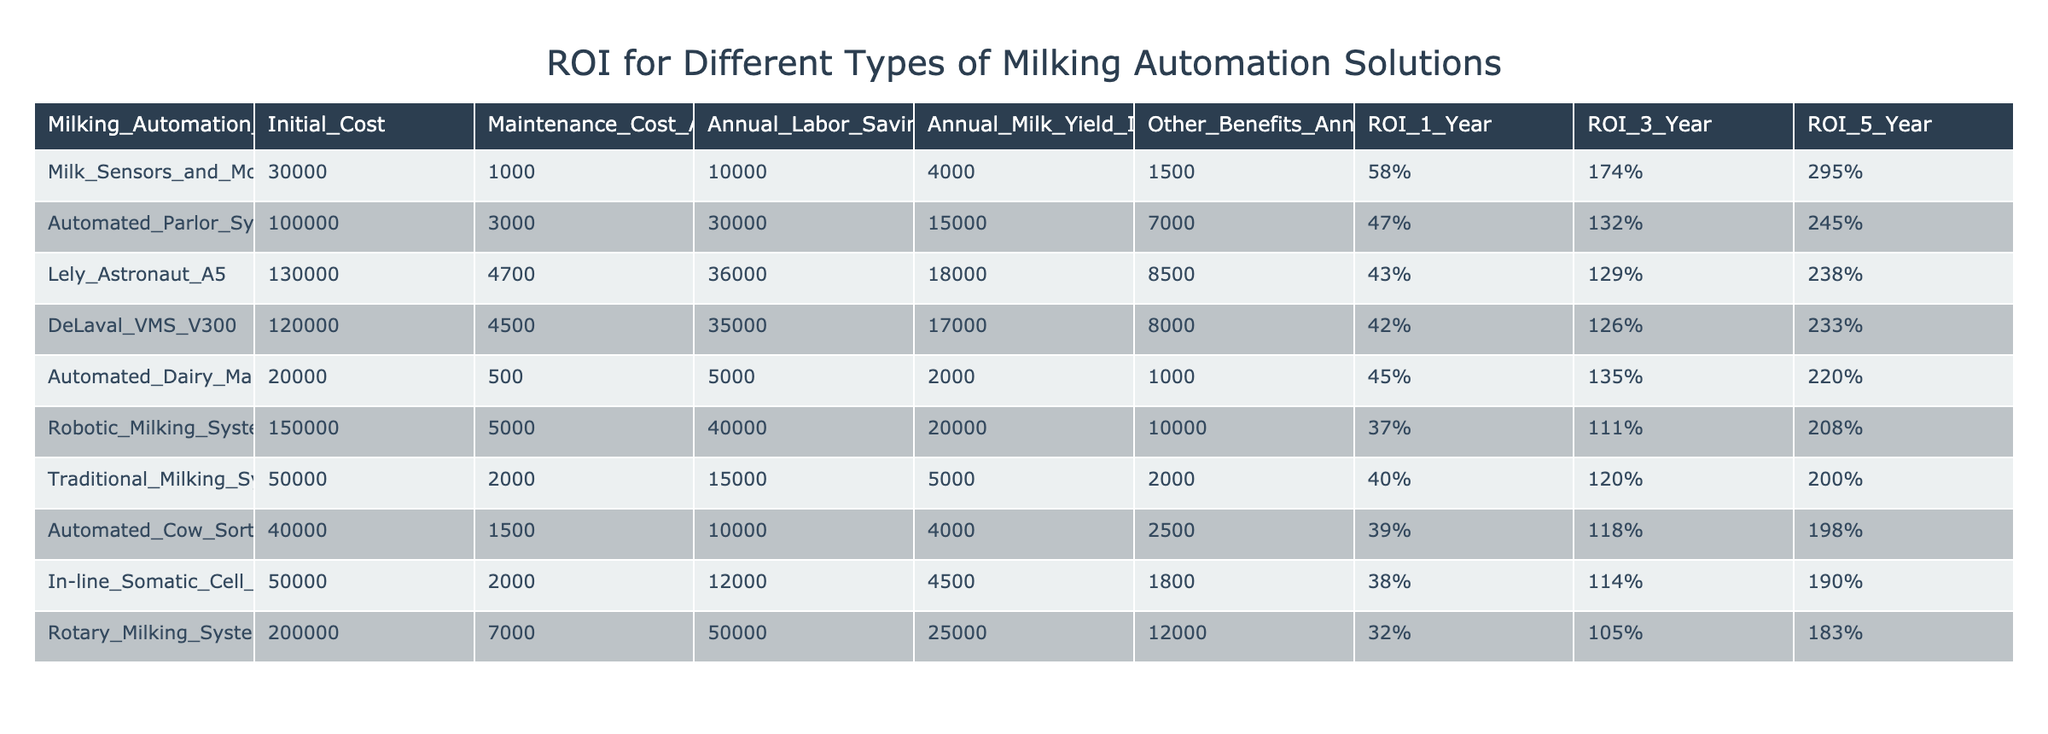What is the ROI after 1 year for Milk Sensors and Monitoring Systems? The table shows that the ROI after 1 year for Milk Sensors and Monitoring Systems is listed as 58%.
Answer: 58% Which milking automation solution has the highest ROI over 5 years? By examining the ROI for 5 years in the table, Milk Sensors and Monitoring Systems has the highest value at 295%.
Answer: 295% Is the Annual Labor Savings for Automated Dairy Management Software greater than that of Traditional Milking Systems? The Annual Labor Savings for Automated Dairy Management Software is 5000, while for Traditional Milking Systems, it is 15000. Therefore, it is not greater.
Answer: No What is the combined Annual Milk Yield Improvement for Automated Parlor Systems and Lely Astronaut A5? The Annual Milk Yield Improvement for Automated Parlor Systems is 15000 and for Lely Astronaut A5 is 18000. Adding these values together gives 15000 + 18000 = 33000.
Answer: 33000 Do both Robotic Milking Systems and DeLaval VMS V300 have similar maintenance costs annually? Robotic Milking Systems have an annual maintenance cost of 5000, while DeLaval VMS V300 has 4500. These amounts are quite close but not exactly the same, therefore they do not have similar costs.
Answer: No What is the difference in Initial Cost between Rotary Milking Systems and Traditional Milking Systems? The Initial Cost of Rotary Milking Systems is 200000, and for Traditional Milking Systems it is 50000. The difference is 200000 - 50000 = 150000.
Answer: 150000 How many solutions have an ROI after 3 years of more than 120%? The ROI after 3 years of more than 120% can be counted by checking the values in the table: Automated Parlor Systems (132%), Milk Sensors and Monitoring Systems (174%), Automated Dairy Management Software (135%), DeLaval VMS V300 (126%), and Lely Astronaut A5 (129%). That makes a total of 5 solutions.
Answer: 5 Are the Other Benefits Annual for Automated Cow Sorting Gates greater than that for Robotic Milking Systems? The Other Benefits Annual for Automated Cow Sorting Gates is 2500, while for Robotic Milking Systems it is 10000. Therefore, it is not greater.
Answer: No What percentage is the ROI after 1 year for Automated Dairy Management Software compared to the ROI after 1 year for Automated Parlor Systems? The ROI after 1 year for Automated Dairy Management Software is 45% and for Automated Parlor Systems is 47%. The percentage comparison is calculated as 45% / 47% = 0.9574, which is about 95.74%.
Answer: 95.74% 